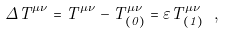<formula> <loc_0><loc_0><loc_500><loc_500>\Delta T ^ { \mu \nu } = T ^ { \mu \nu } - T ^ { \mu \nu } _ { ( 0 ) } = \varepsilon T ^ { \mu \nu } _ { ( 1 ) } \ ,</formula> 